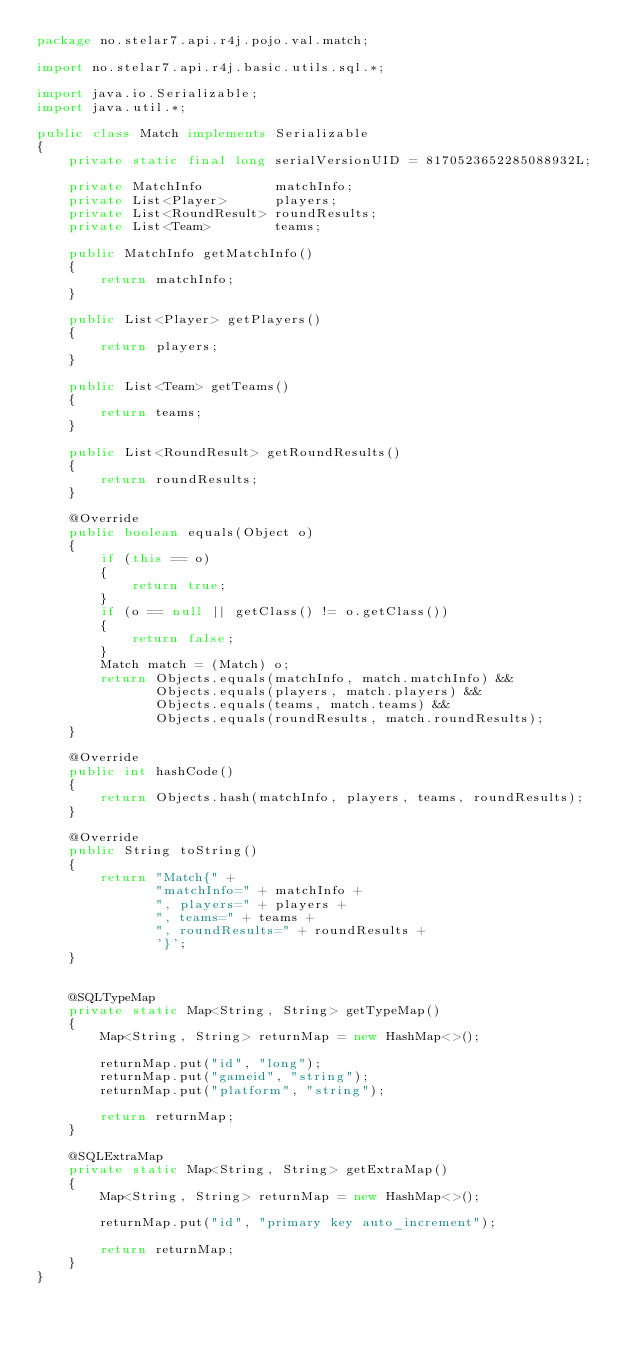Convert code to text. <code><loc_0><loc_0><loc_500><loc_500><_Java_>package no.stelar7.api.r4j.pojo.val.match;

import no.stelar7.api.r4j.basic.utils.sql.*;

import java.io.Serializable;
import java.util.*;

public class Match implements Serializable
{
    private static final long serialVersionUID = 8170523652285088932L;
    
    private MatchInfo         matchInfo;
    private List<Player>      players;
    private List<RoundResult> roundResults;
    private List<Team>        teams;
    
    public MatchInfo getMatchInfo()
    {
        return matchInfo;
    }
    
    public List<Player> getPlayers()
    {
        return players;
    }
    
    public List<Team> getTeams()
    {
        return teams;
    }
    
    public List<RoundResult> getRoundResults()
    {
        return roundResults;
    }
    
    @Override
    public boolean equals(Object o)
    {
        if (this == o)
        {
            return true;
        }
        if (o == null || getClass() != o.getClass())
        {
            return false;
        }
        Match match = (Match) o;
        return Objects.equals(matchInfo, match.matchInfo) &&
               Objects.equals(players, match.players) &&
               Objects.equals(teams, match.teams) &&
               Objects.equals(roundResults, match.roundResults);
    }
    
    @Override
    public int hashCode()
    {
        return Objects.hash(matchInfo, players, teams, roundResults);
    }
    
    @Override
    public String toString()
    {
        return "Match{" +
               "matchInfo=" + matchInfo +
               ", players=" + players +
               ", teams=" + teams +
               ", roundResults=" + roundResults +
               '}';
    }
    
    
    @SQLTypeMap
    private static Map<String, String> getTypeMap()
    {
        Map<String, String> returnMap = new HashMap<>();
        
        returnMap.put("id", "long");
        returnMap.put("gameid", "string");
        returnMap.put("platform", "string");
        
        return returnMap;
    }
    
    @SQLExtraMap
    private static Map<String, String> getExtraMap()
    {
        Map<String, String> returnMap = new HashMap<>();
        
        returnMap.put("id", "primary key auto_increment");
        
        return returnMap;
    }
}
</code> 